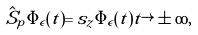Convert formula to latex. <formula><loc_0><loc_0><loc_500><loc_500>\hat { S } _ { p } \Phi _ { \epsilon } ( t ) = s _ { z } \Phi _ { \epsilon } ( t ) t \rightarrow \pm \infty ,</formula> 